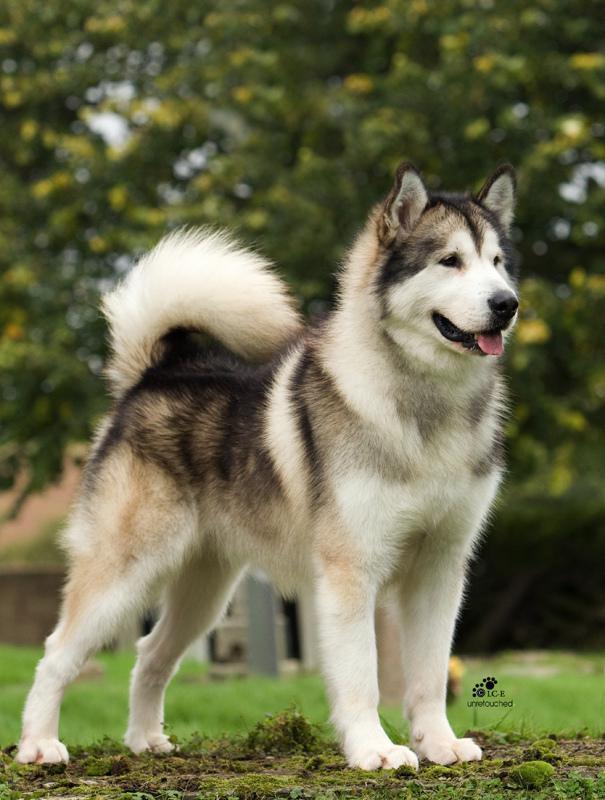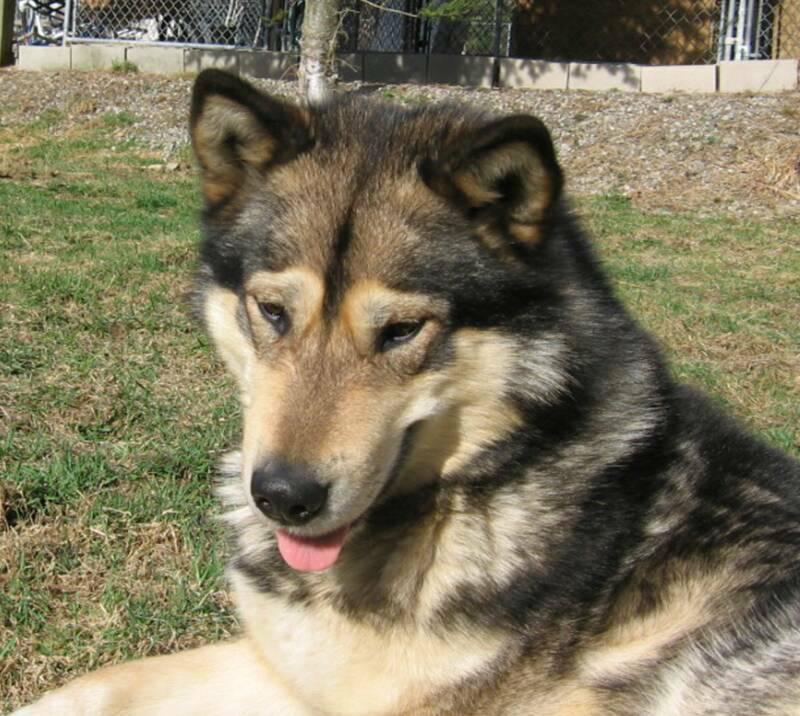The first image is the image on the left, the second image is the image on the right. For the images displayed, is the sentence "The left and right image contains the same number of dogs." factually correct? Answer yes or no. Yes. The first image is the image on the left, the second image is the image on the right. For the images displayed, is the sentence "There are exactly three dogs." factually correct? Answer yes or no. No. 